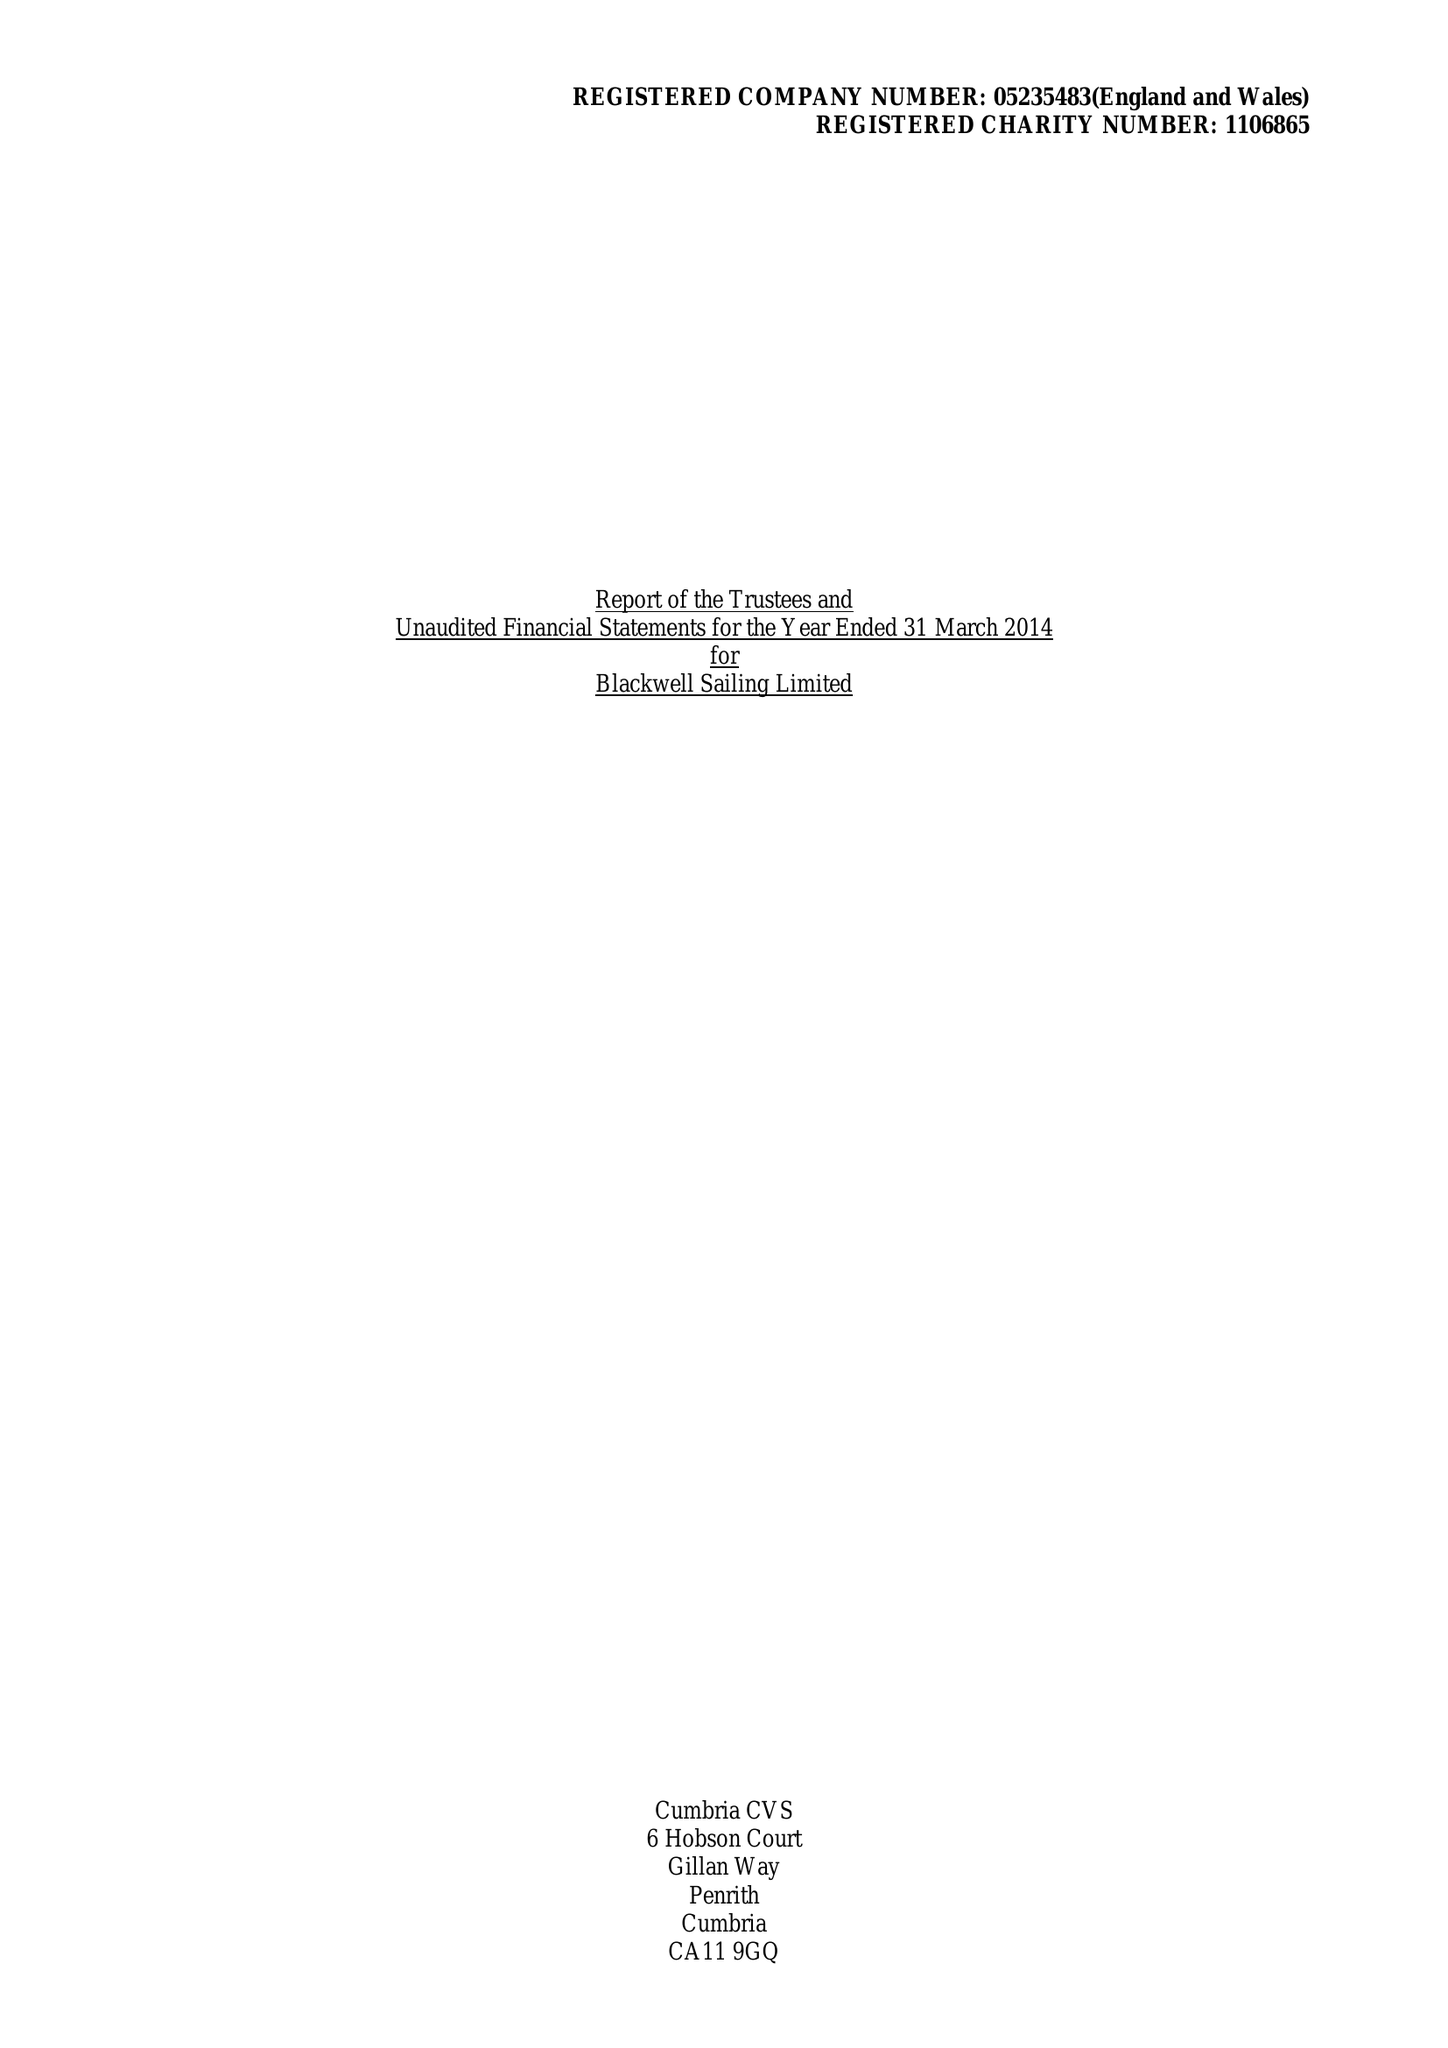What is the value for the charity_number?
Answer the question using a single word or phrase. 1106865 